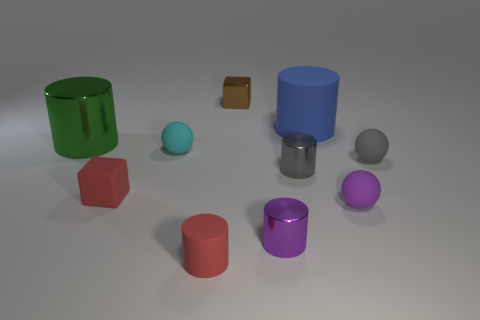Does the cube that is in front of the tiny gray sphere have the same color as the rubber cylinder on the left side of the blue matte object?
Your answer should be compact. Yes. What number of other objects are there of the same color as the tiny matte cube?
Make the answer very short. 1. How many tiny shiny things are behind the tiny metal cylinder that is behind the purple sphere?
Offer a terse response. 1. Is there a rubber cylinder of the same color as the rubber cube?
Give a very brief answer. Yes. Is the green cylinder the same size as the gray cylinder?
Make the answer very short. No. Is the color of the tiny shiny cube the same as the rubber cube?
Keep it short and to the point. No. What material is the cylinder that is behind the shiny thing to the left of the red rubber cube?
Your response must be concise. Rubber. What material is the gray object that is the same shape as the large green object?
Ensure brevity in your answer.  Metal. Do the matte sphere that is in front of the red cube and the green cylinder have the same size?
Offer a terse response. No. What number of matte objects are tiny cyan cylinders or brown things?
Provide a short and direct response. 0. 